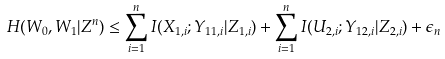Convert formula to latex. <formula><loc_0><loc_0><loc_500><loc_500>H ( W _ { 0 } , W _ { 1 } | Z ^ { n } ) & \leq \sum _ { i = 1 } ^ { n } I ( X _ { 1 , i } ; Y _ { 1 1 , i } | Z _ { 1 , i } ) + \sum _ { i = 1 } ^ { n } I ( U _ { 2 , i } ; Y _ { 1 2 , i } | Z _ { 2 , i } ) + \epsilon _ { n }</formula> 